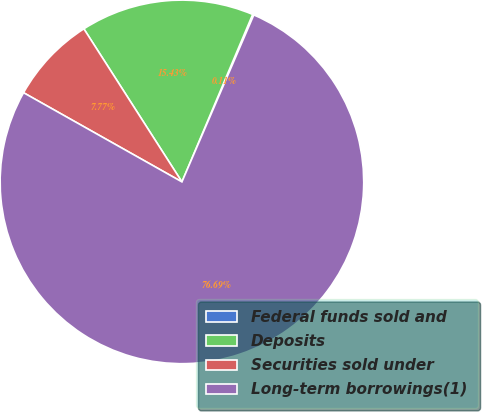Convert chart. <chart><loc_0><loc_0><loc_500><loc_500><pie_chart><fcel>Federal funds sold and<fcel>Deposits<fcel>Securities sold under<fcel>Long-term borrowings(1)<nl><fcel>0.11%<fcel>15.43%<fcel>7.77%<fcel>76.7%<nl></chart> 